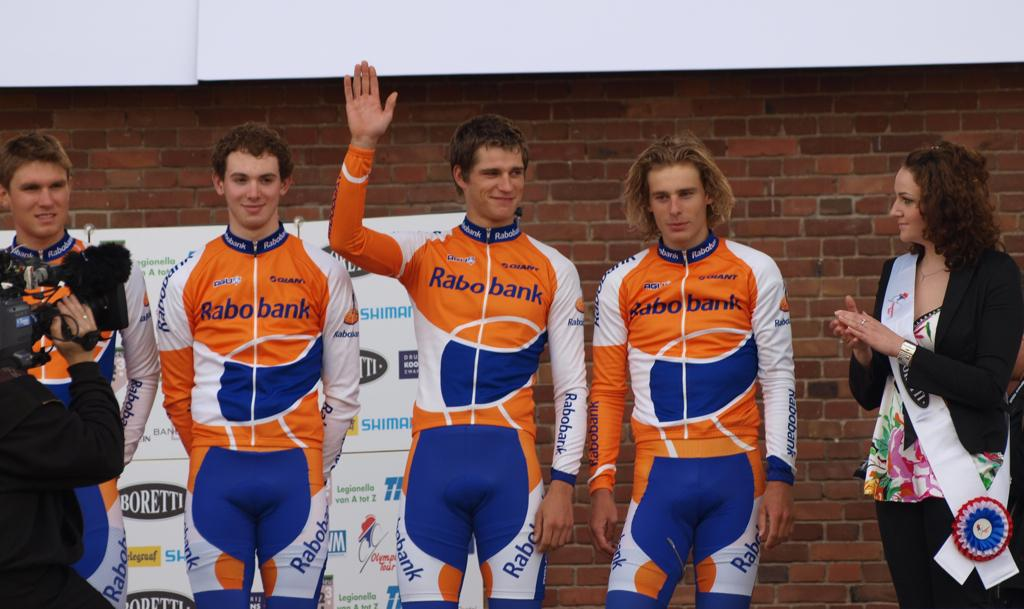<image>
Present a compact description of the photo's key features. Rabobank is a sponsor for the athletes in the orange and blue uniforms. 